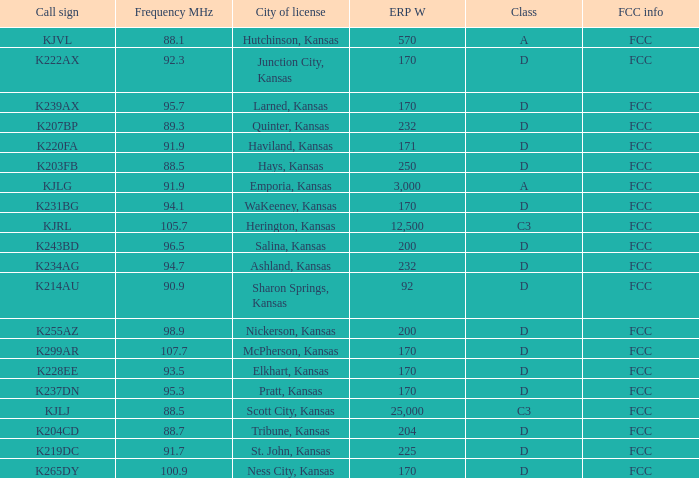ERP W that has a Class of d, and a Call sign of k299ar is what total number? 1.0. 